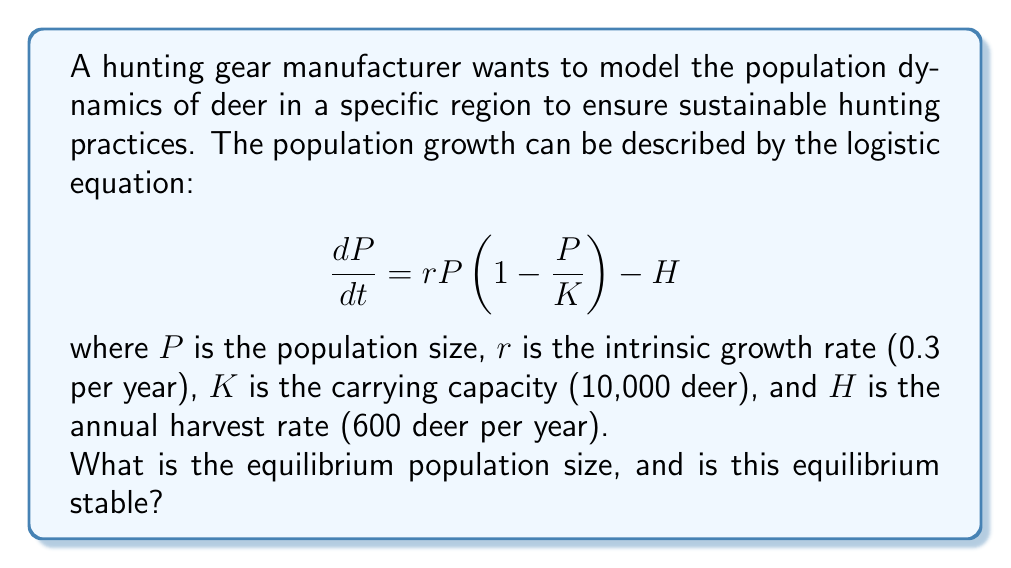Teach me how to tackle this problem. To find the equilibrium population size, we set $\frac{dP}{dt} = 0$:

$$0 = rP(1 - \frac{P}{K}) - H$$

Substituting the given values:

$$0 = 0.3P(1 - \frac{P}{10000}) - 600$$

Simplifying:

$$0 = 0.3P - 0.00003P^2 - 600$$

Rearranging to standard quadratic form:

$$0.00003P^2 - 0.3P + 600 = 0$$

Using the quadratic formula $\frac{-b \pm \sqrt{b^2 - 4ac}}{2a}$, we get:

$$P = \frac{0.3 \pm \sqrt{0.3^2 - 4(0.00003)(600)}}{2(0.00003)}$$

$$P = \frac{0.3 \pm \sqrt{0.09 - 0.072}}{0.00006}$$

$$P = \frac{0.3 \pm 0.1}{0.00006}$$

This gives us two solutions:
$P_1 = \frac{0.4}{0.00006} = 6666.67$
$P_2 = \frac{0.2}{0.00006} = 3333.33$

To determine stability, we examine the derivative of $\frac{dP}{dt}$ with respect to $P$:

$$\frac{d}{dP}(\frac{dP}{dt}) = r - \frac{2rP}{K} = 0.3 - \frac{0.6P}{10000}$$

At $P_1 = 6666.67$, this derivative is negative, indicating a stable equilibrium.
At $P_2 = 3333.33$, this derivative is positive, indicating an unstable equilibrium.

Therefore, the stable equilibrium population size is approximately 6,667 deer.
Answer: 6,667 deer (stable equilibrium) 